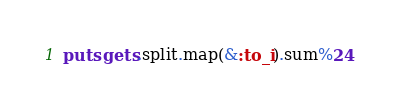Convert code to text. <code><loc_0><loc_0><loc_500><loc_500><_Ruby_>puts gets.split.map(&:to_i).sum%24</code> 